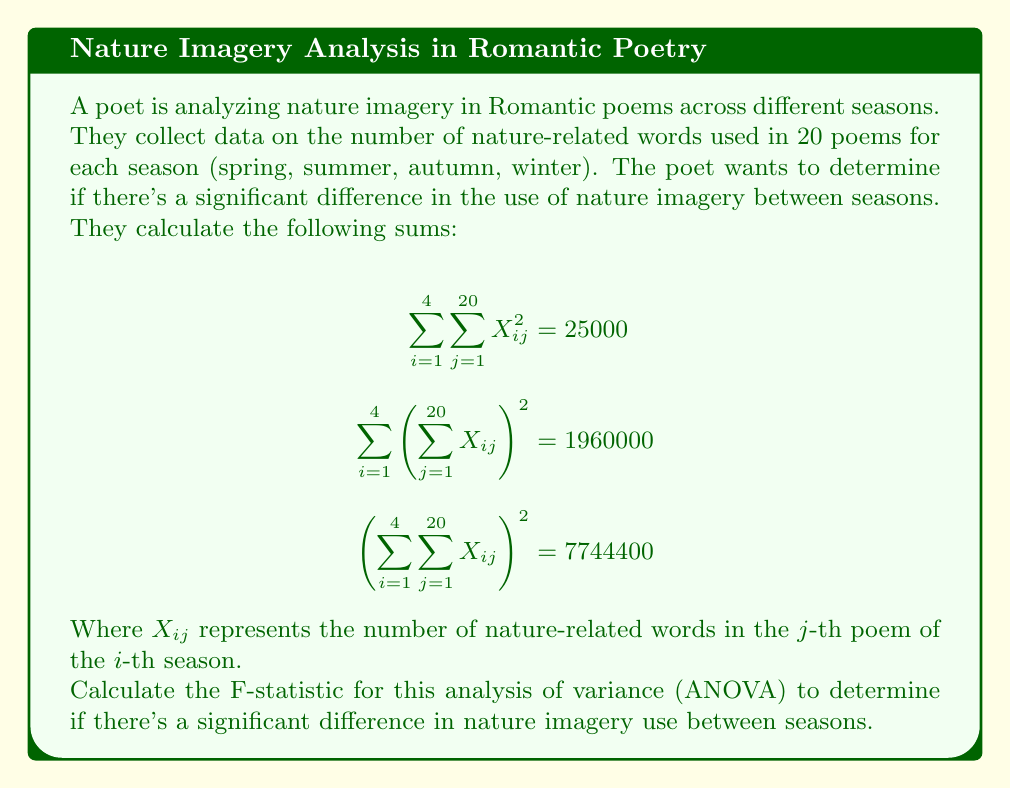Could you help me with this problem? To calculate the F-statistic for this ANOVA, we need to follow these steps:

1. Calculate the Sum of Squares Total (SST):
   $$SST = \sum_{i=1}^{4} \sum_{j=1}^{20} X_{ij}^2 - \frac{(\sum_{i=1}^{4} \sum_{j=1}^{20} X_{ij})^2}{N}$$
   Where $N = 4 \times 20 = 80$ (total number of poems)
   $$SST = 25000 - \frac{7744400}{80} = 25000 - 96805 = 3195$$

2. Calculate the Sum of Squares Between (SSB):
   $$SSB = \frac{1}{n}\sum_{i=1}^{4} (\sum_{j=1}^{20} X_{ij})^2 - \frac{(\sum_{i=1}^{4} \sum_{j=1}^{20} X_{ij})^2}{N}$$
   Where $n = 20$ (number of poems per season)
   $$SSB = \frac{1960000}{20} - 96805 = 98000 - 96805 = 1195$$

3. Calculate the Sum of Squares Within (SSW):
   $$SSW = SST - SSB = 3195 - 1195 = 2000$$

4. Calculate the degrees of freedom:
   - Between groups: $df_B = 4 - 1 = 3$
   - Within groups: $df_W = 80 - 4 = 76$

5. Calculate the Mean Square Between (MSB) and Mean Square Within (MSW):
   $$MSB = \frac{SSB}{df_B} = \frac{1195}{3} = 398.33$$
   $$MSW = \frac{SSW}{df_W} = \frac{2000}{76} = 26.32$$

6. Calculate the F-statistic:
   $$F = \frac{MSB}{MSW} = \frac{398.33}{26.32} = 15.13$$

Therefore, the F-statistic for this ANOVA is 15.13.
Answer: $F = 15.13$ 